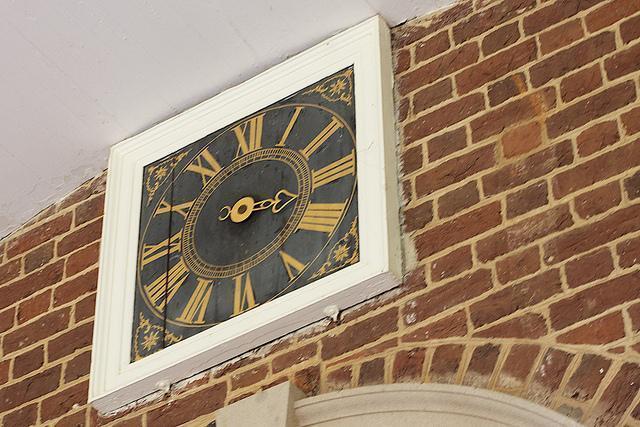How many airplanes are on the runway?
Give a very brief answer. 0. 